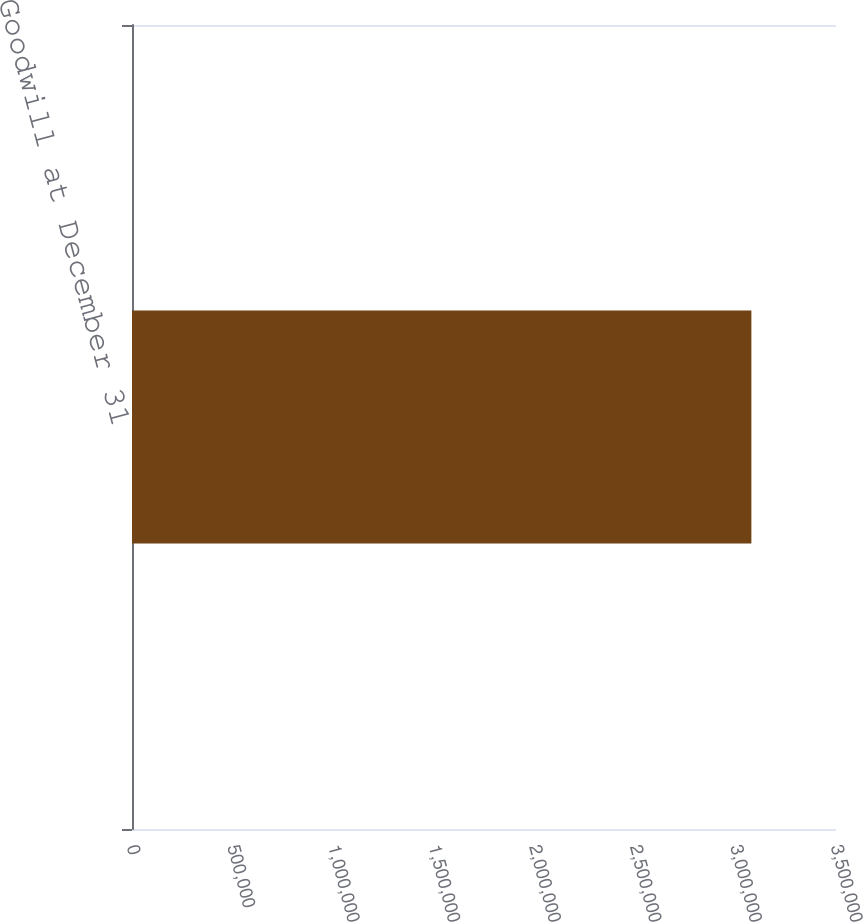Convert chart to OTSL. <chart><loc_0><loc_0><loc_500><loc_500><bar_chart><fcel>Goodwill at December 31<nl><fcel>3.07927e+06<nl></chart> 